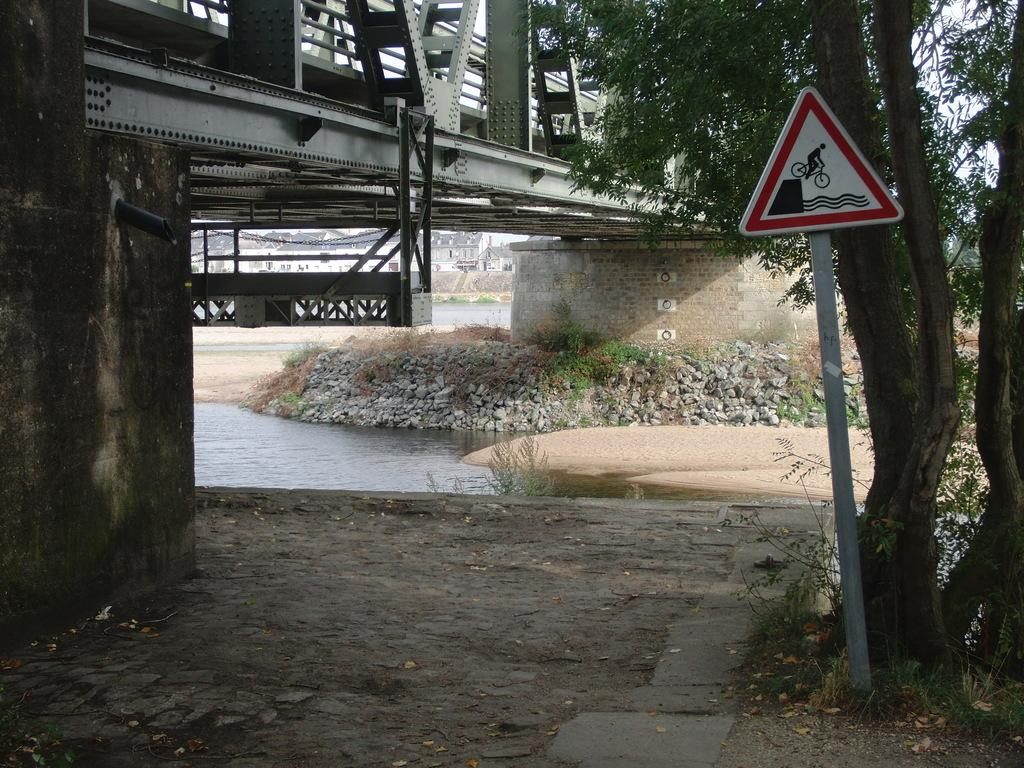What is attached to the pole in the image? There is a sign board attached to a pole in the image. What can be seen in the background of the image? Water, trees with green color, and a bridge are visible in the background of the image. What is the color of the sky in the image? The sky appears to be white in color. How does the system of trees and water work together in the image? There is no mention of a system in the image; it simply shows trees, water, and a bridge in the background. 